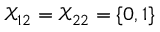Convert formula to latex. <formula><loc_0><loc_0><loc_500><loc_500>\mathcal { X } _ { 1 2 } = \mathcal { X } _ { 2 2 } = \{ 0 , 1 \}</formula> 